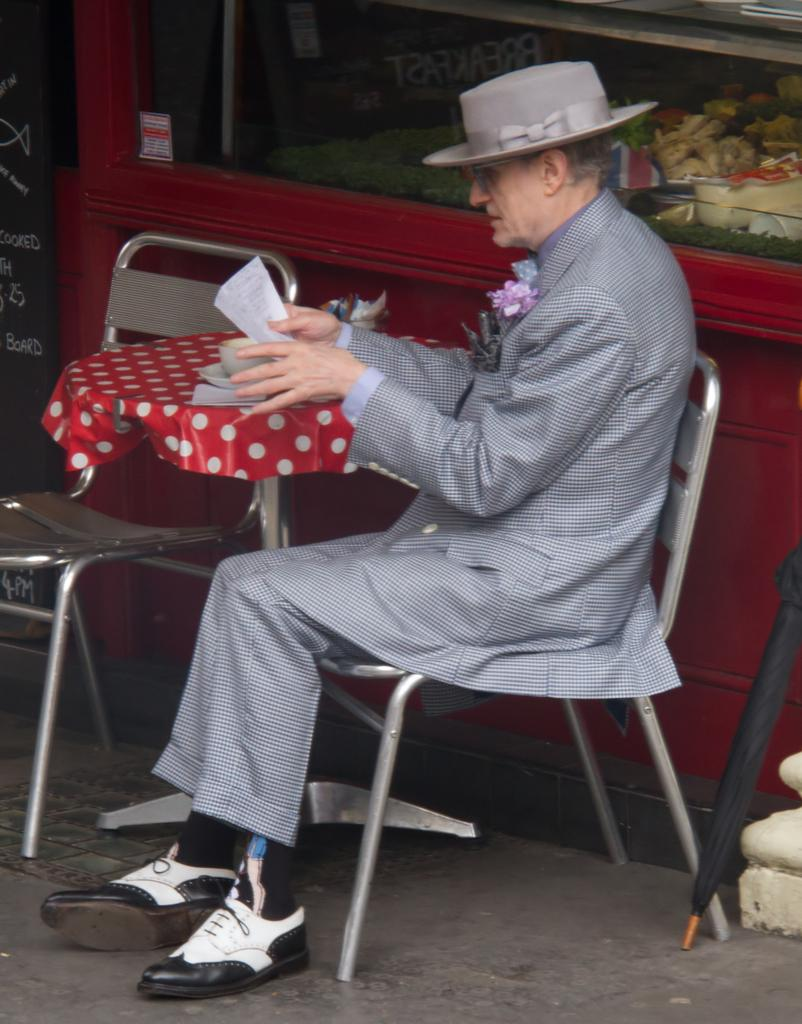What is the man in the image doing? The man is sitting on a chair in the image. Can you describe the man's attire? The man is wearing a hat. What is the man holding in his hand? The man is holding a paper in his hand. How many chairs are visible in the image? There are two chairs visible in the image. What other piece of furniture is present in the image? There is a table in the image. What object is associated with protection from the sun or rain? There is an umbrella in the image. What type of jelly can be seen dripping from the man's hat in the image? There is no jelly present in the image, and the man's hat is not shown to be dripping anything. What month is it in the image? The image does not provide any information about the month or time of year. 